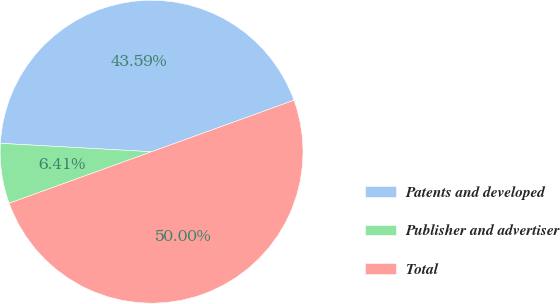<chart> <loc_0><loc_0><loc_500><loc_500><pie_chart><fcel>Patents and developed<fcel>Publisher and advertiser<fcel>Total<nl><fcel>43.59%<fcel>6.41%<fcel>50.0%<nl></chart> 